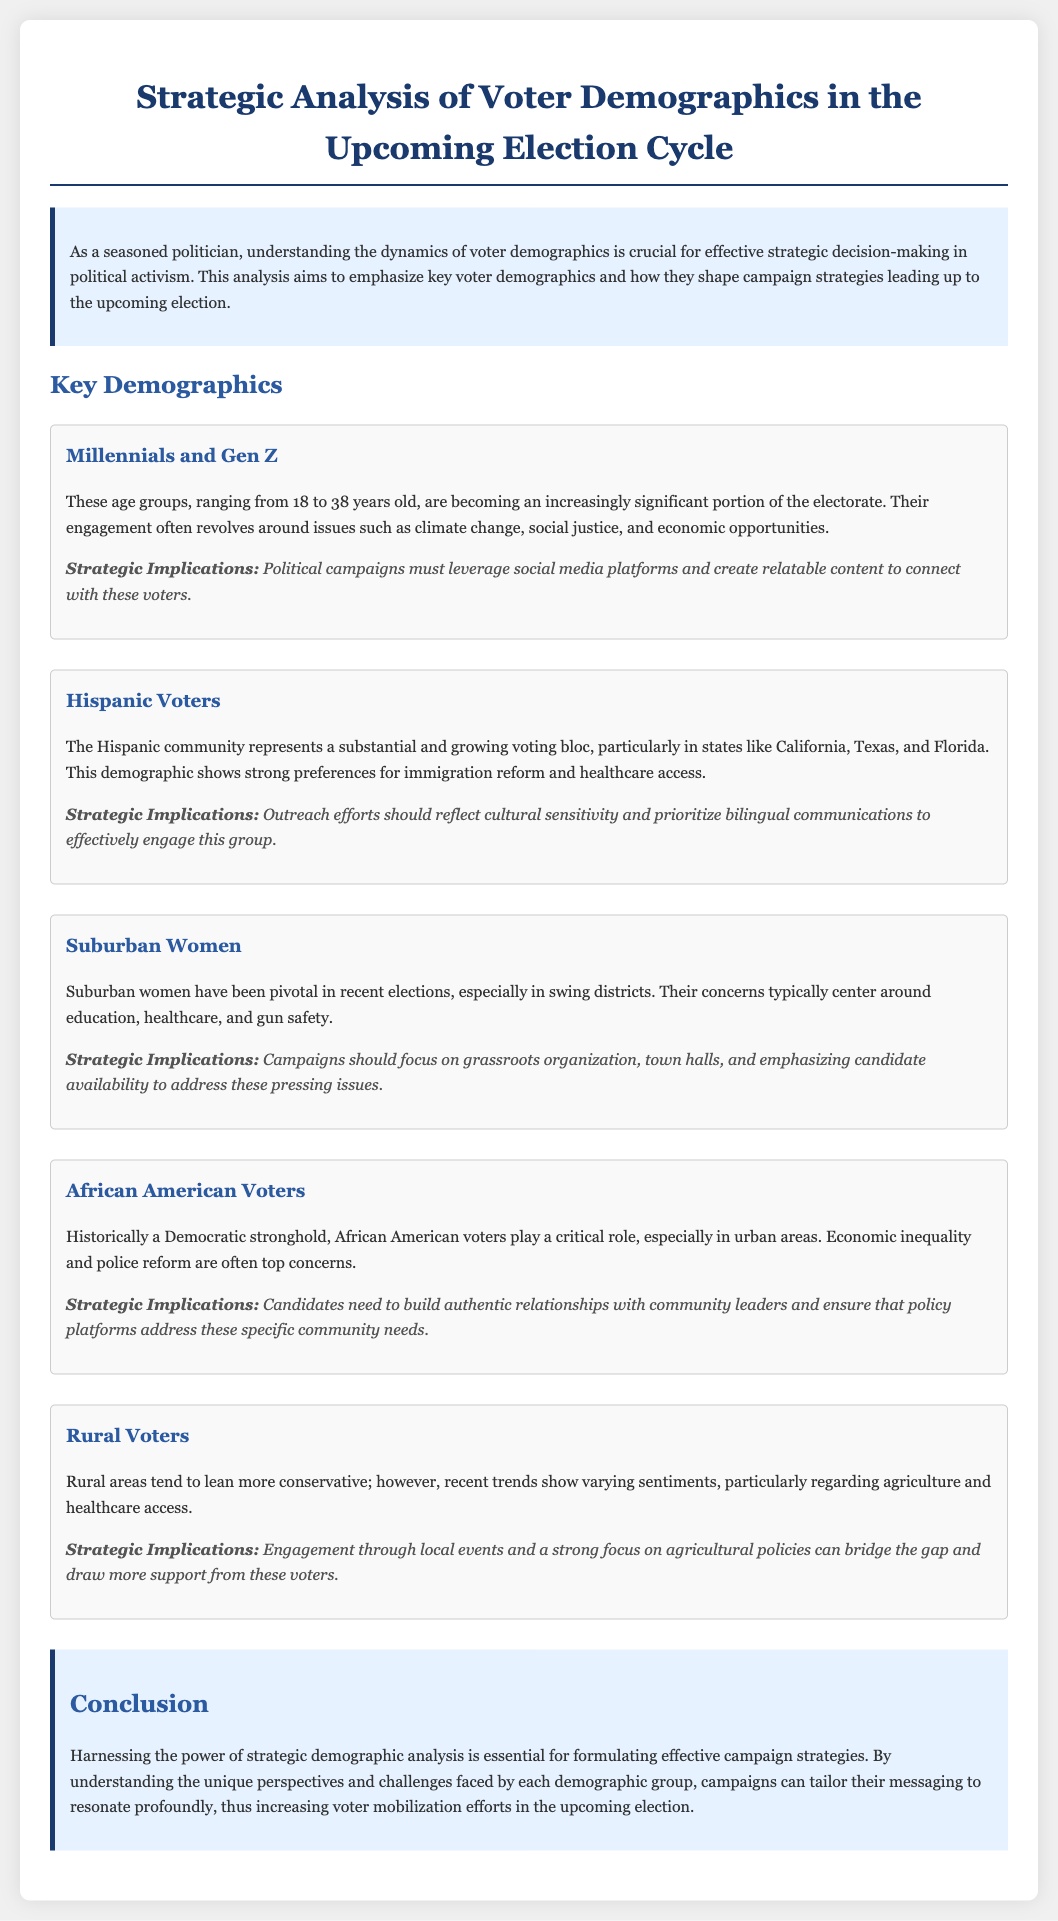What is the age range for Millennials and Gen Z? The age range mentioned for Millennials and Gen Z is from 18 to 38 years old.
Answer: 18 to 38 years old Which demographic group is emphasized for their concerns about education and healthcare? The concerns about education and healthcare are highlighted for suburban women.
Answer: Suburban Women What are two key issues for Hispanic voters? The document states that Hispanic voters show strong preferences for immigration reform and healthcare access.
Answer: Immigration reform and healthcare access Which demographic group represents a significant voting bloc in California, Texas, and Florida? The Hispanic community is noted as a substantial and growing voting bloc in these states.
Answer: Hispanic Voters What is a strategic implication for engaging rural voters? Engagement through local events and a focus on agricultural policies are mentioned as strategies for rural voters.
Answer: Local events and agricultural policies Which demographic group is suggested to have a strong presence in urban areas? African American voters are indicated as having a critical role in urban areas.
Answer: African American Voters What type of communication is recommended for outreach to Hispanic voters? The document emphasizes the importance of bilingual communications for effective engagement.
Answer: Bilingual communications What should political campaigns leverage to connect with Millennials and Gen Z? Political campaigns must leverage social media platforms to connect with these voters.
Answer: Social media platforms What major concern is shared by African American voters? Economic inequality is one of the top concerns for African American voters according to the document.
Answer: Economic inequality 